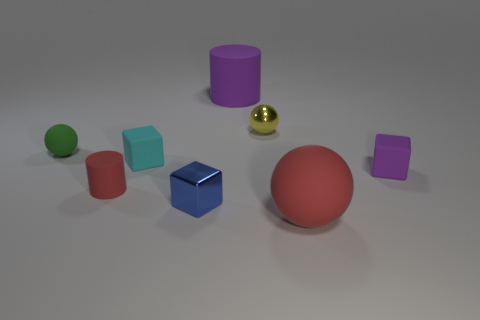Add 2 tiny brown metal balls. How many objects exist? 10 Subtract all cylinders. How many objects are left? 6 Add 1 shiny balls. How many shiny balls exist? 2 Subtract 0 green cylinders. How many objects are left? 8 Subtract all small brown cylinders. Subtract all tiny blue shiny cubes. How many objects are left? 7 Add 3 purple matte cylinders. How many purple matte cylinders are left? 4 